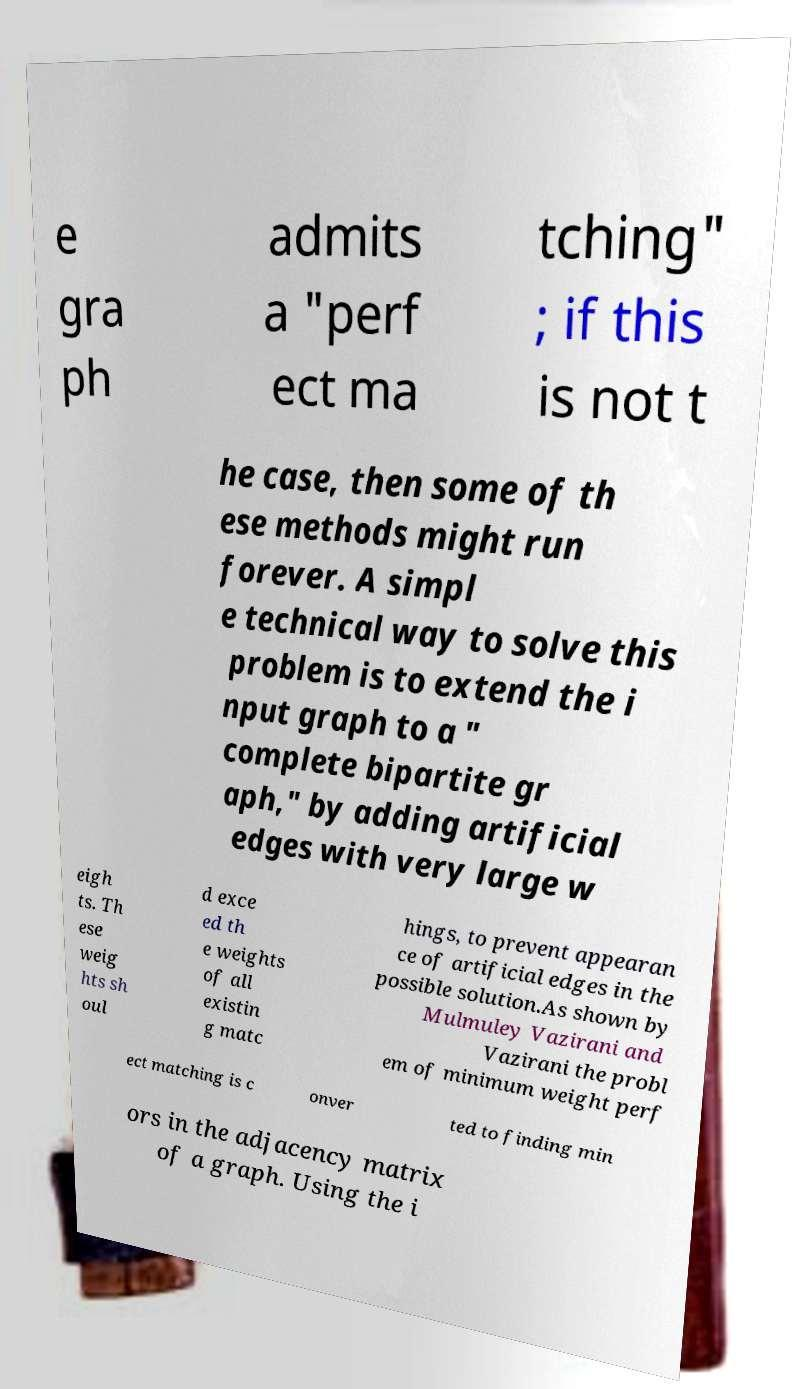Could you assist in decoding the text presented in this image and type it out clearly? e gra ph admits a "perf ect ma tching" ; if this is not t he case, then some of th ese methods might run forever. A simpl e technical way to solve this problem is to extend the i nput graph to a " complete bipartite gr aph," by adding artificial edges with very large w eigh ts. Th ese weig hts sh oul d exce ed th e weights of all existin g matc hings, to prevent appearan ce of artificial edges in the possible solution.As shown by Mulmuley Vazirani and Vazirani the probl em of minimum weight perf ect matching is c onver ted to finding min ors in the adjacency matrix of a graph. Using the i 